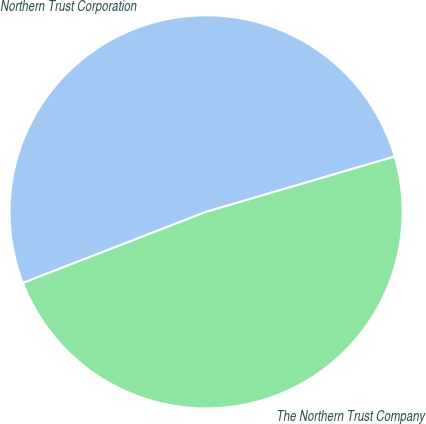Convert chart to OTSL. <chart><loc_0><loc_0><loc_500><loc_500><pie_chart><fcel>Northern Trust Corporation<fcel>The Northern Trust Company<nl><fcel>51.35%<fcel>48.65%<nl></chart> 